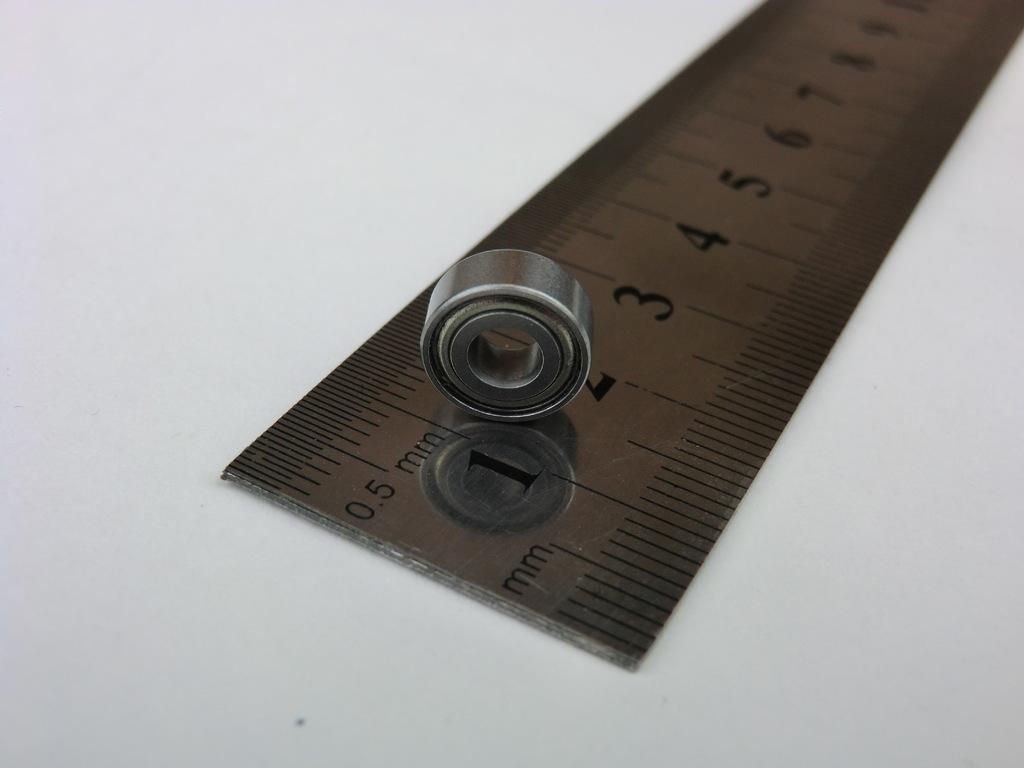<image>
Share a concise interpretation of the image provided. a cylinder bearing on a ruler in mm with numbers 1 - 9 